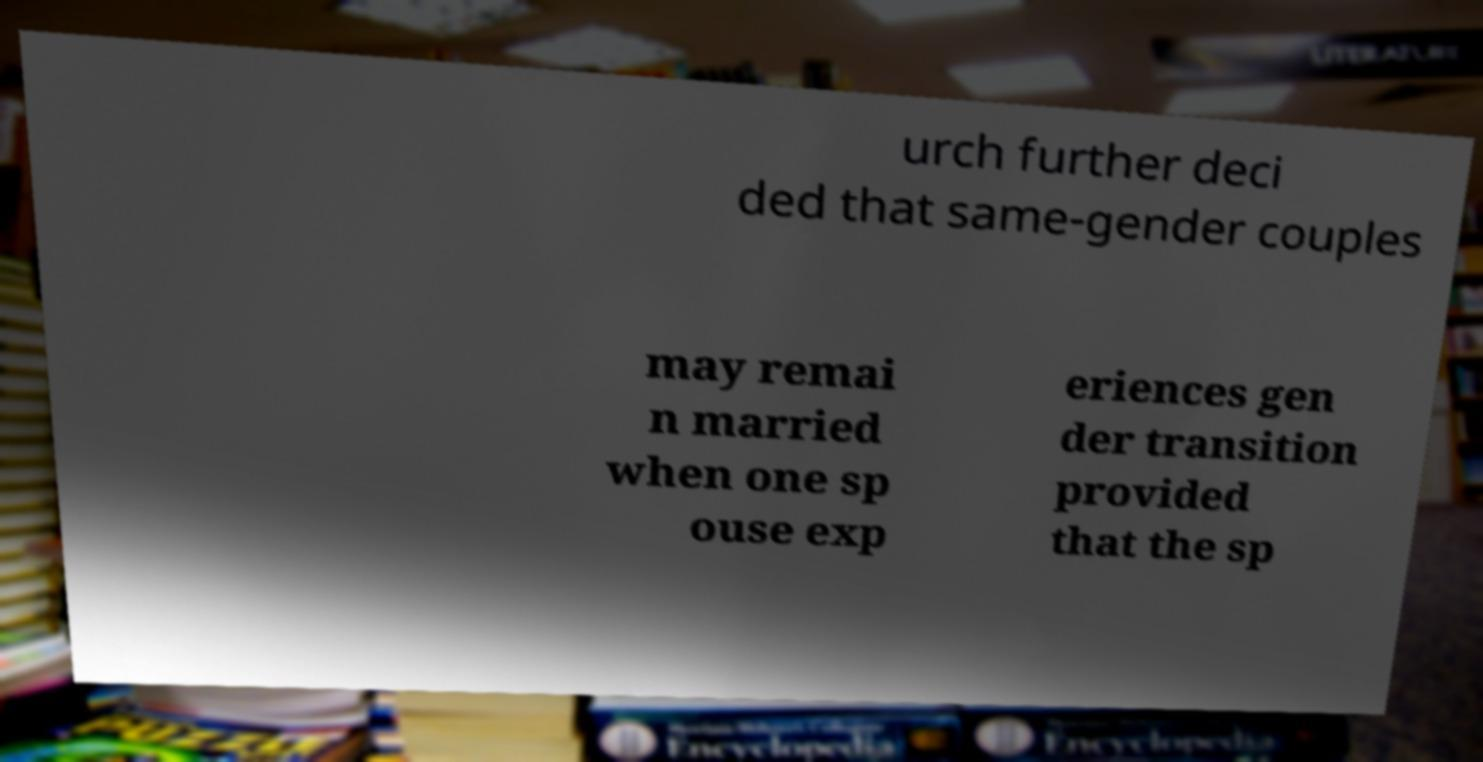Could you extract and type out the text from this image? urch further deci ded that same-gender couples may remai n married when one sp ouse exp eriences gen der transition provided that the sp 